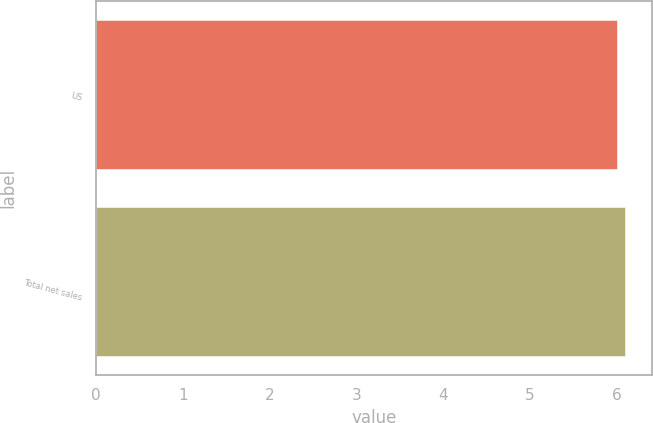Convert chart. <chart><loc_0><loc_0><loc_500><loc_500><bar_chart><fcel>US<fcel>Total net sales<nl><fcel>6<fcel>6.1<nl></chart> 